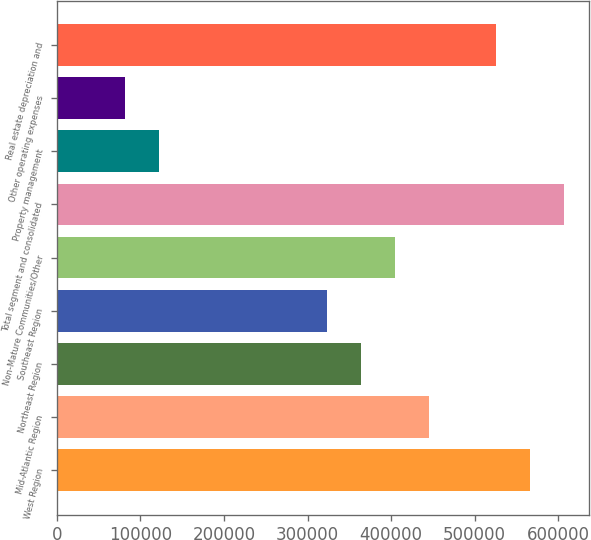Convert chart. <chart><loc_0><loc_0><loc_500><loc_500><bar_chart><fcel>West Region<fcel>Mid-Atlantic Region<fcel>Northeast Region<fcel>Southeast Region<fcel>Non-Mature Communities/Other<fcel>Total segment and consolidated<fcel>Property management<fcel>Other operating expenses<fcel>Real estate depreciation and<nl><fcel>565987<fcel>444808<fcel>364022<fcel>323629<fcel>404415<fcel>606380<fcel>121663<fcel>81270.2<fcel>525594<nl></chart> 